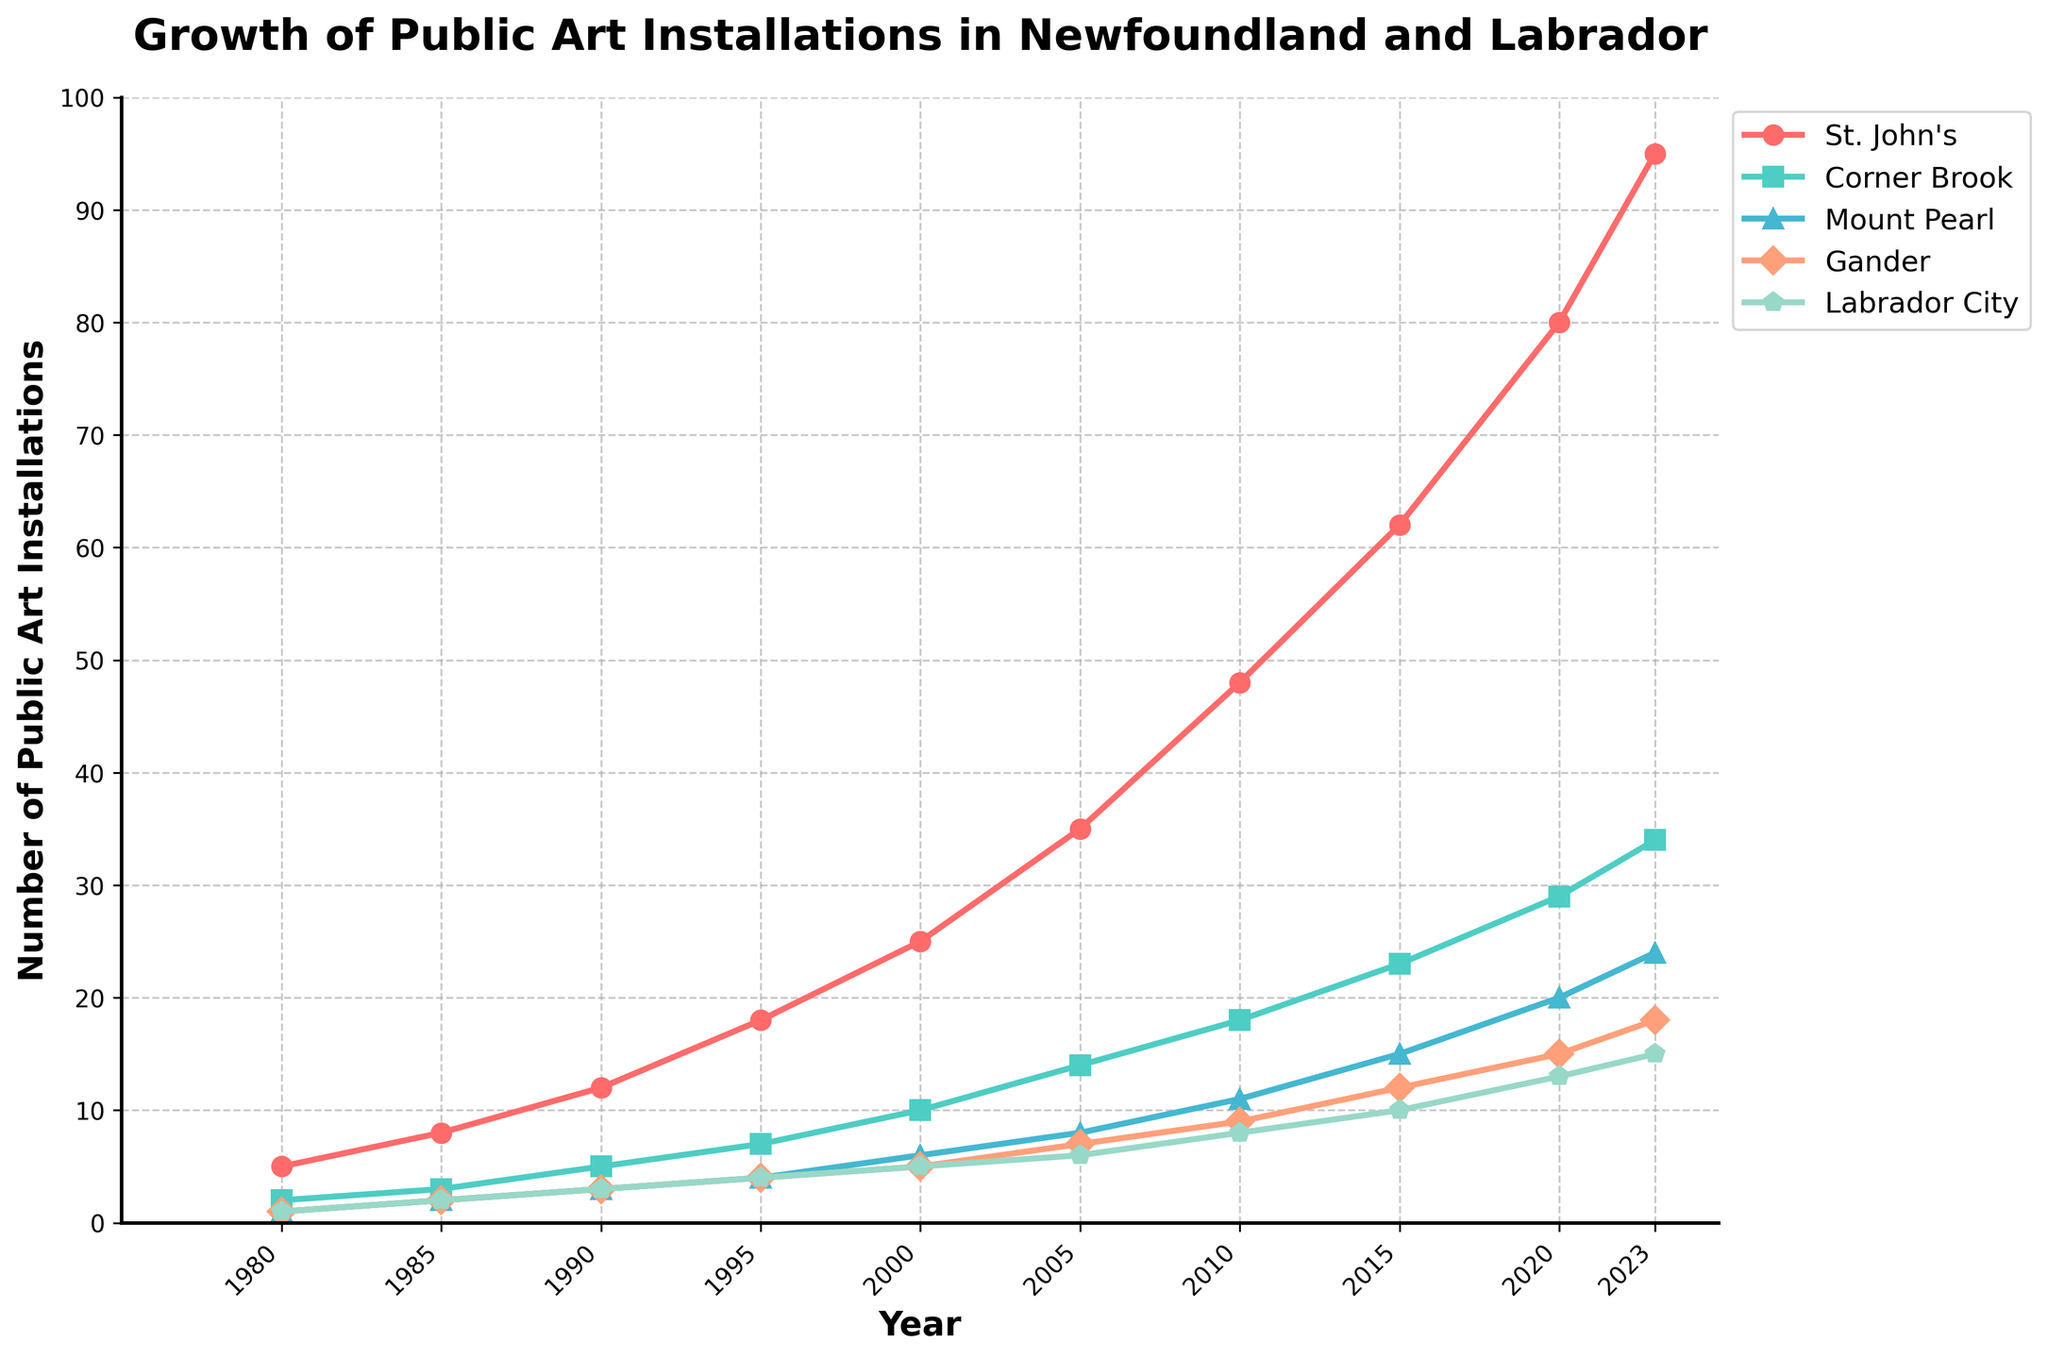What year did St. John's first reach 50 public art installations? To find this, look at the line for St. John's (typically the topmost line or the one with the highest values since 1980) and find the first year the value reaches or exceeds 50.
Answer: 2010 Which city had the smallest increase in the number of installations between 2000 and 2023? Calculate the difference in installations between 2023 and 2000 for each city and compare. (For St. John's: 95-25 = 70, Corner Brook: 34-10 = 24, Mount Pearl: 24-6 = 18, Gander: 18-5 = 13, Labrador City: 15-5 = 10).
Answer: Labrador City Which city had the highest number of public art installations in 1995? Refer to the data point for 1995 and compare the values for all cities.
Answer: St. John's What is the total number of public art installations across all cities in 2020? Sum the values for all cities in 2020. (St. John's: 80, Corner Brook: 29, Mount Pearl: 20, Gander: 15, Labrador City: 13. 80 + 29 + 20 + 15 + 13 = 157).
Answer: 157 In which time period did Corner Brook see its largest increase in the number of art installations? Calculate the increments between consecutive data points for Corner Brook and find the largest. (1980-1985: 3-2 = 1, 1985-1990: 5-3 = 2, 1990-1995: 7-5 = 2, 1995-2000: 10-7 = 3, 2000-2005: 14-10 = 4, 2005-2010: 18-14 = 4, 2010-2015: 23-18 = 5, 2015-2020: 29-23 = 6, 2020-2023: 34-29 = 5).
Answer: 2015-2020 What is the average yearly growth rate for Gander from 1980 to 2023? Calculate the total increase in installations for Gander (18-1 = 17) and divide it by the number of years (2023-1980 = 43). (17/43 ≈ 0.395 installations per year)
Answer: Approximately 0.395 How many years did it take for Labrador City to reach 10 installations from 1980? Look at the Labrador City line and find the year the installations reach 10, then subtract 1980 from that year. (2005 - 1980 = 25 years).
Answer: 25 Which city had the highest number of installations in 2023 and how many more installations did it have than the city with the second highest number? Identify the city with the highest installations in 2023 and compare it with the city with the second highest. (St. John's: 95, Corner Brook: 34, 95 - 34 = 61).
Answer: St. John's, 61 Between 1990 and 2000, which city, other than St. John's, had the largest increase in public art installations and what was the increase? Exclude St. John's and calculate the differences in installations for each city between 1990 and 2000 (Corner Brook: 10-5=5, Mount Pearl: 6-3=3, Gander: 5-3=2, Labrador City: 5-3=2).
Answer: Corner Brook, 5 